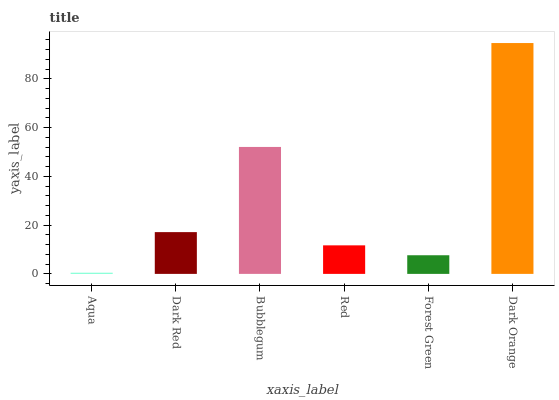Is Aqua the minimum?
Answer yes or no. Yes. Is Dark Orange the maximum?
Answer yes or no. Yes. Is Dark Red the minimum?
Answer yes or no. No. Is Dark Red the maximum?
Answer yes or no. No. Is Dark Red greater than Aqua?
Answer yes or no. Yes. Is Aqua less than Dark Red?
Answer yes or no. Yes. Is Aqua greater than Dark Red?
Answer yes or no. No. Is Dark Red less than Aqua?
Answer yes or no. No. Is Dark Red the high median?
Answer yes or no. Yes. Is Red the low median?
Answer yes or no. Yes. Is Dark Orange the high median?
Answer yes or no. No. Is Dark Orange the low median?
Answer yes or no. No. 